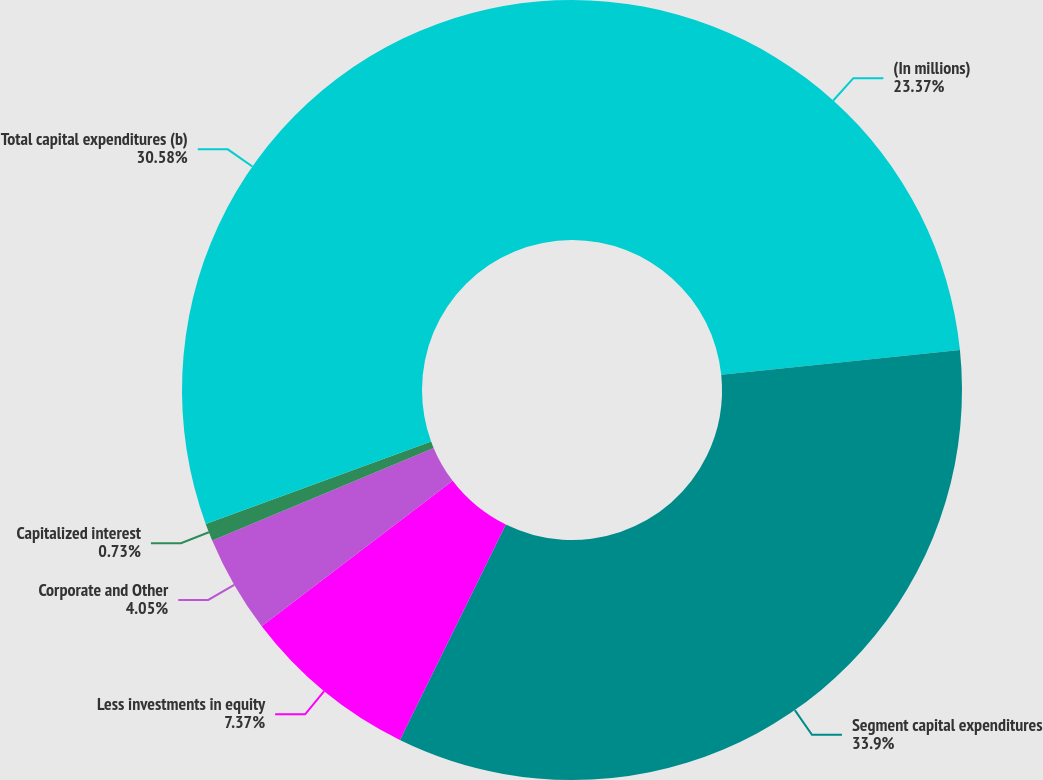Convert chart to OTSL. <chart><loc_0><loc_0><loc_500><loc_500><pie_chart><fcel>(In millions)<fcel>Segment capital expenditures<fcel>Less investments in equity<fcel>Corporate and Other<fcel>Capitalized interest<fcel>Total capital expenditures (b)<nl><fcel>23.37%<fcel>33.91%<fcel>7.37%<fcel>4.05%<fcel>0.73%<fcel>30.58%<nl></chart> 